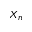<formula> <loc_0><loc_0><loc_500><loc_500>X _ { n }</formula> 